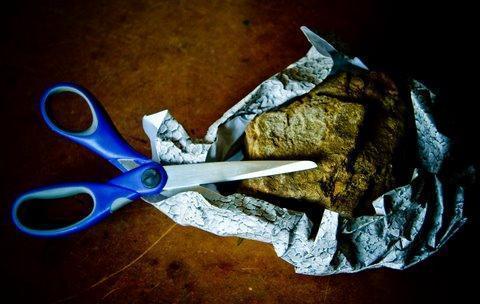How many scissors are in the picture?
Give a very brief answer. 1. 